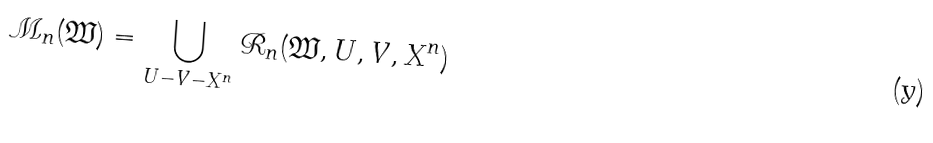<formula> <loc_0><loc_0><loc_500><loc_500>\mathcal { M } _ { n } ( \mathfrak { W } ) = \bigcup _ { U - V - X ^ { n } } \mathcal { R } _ { n } ( \mathfrak { W } , U , V , X ^ { n } )</formula> 